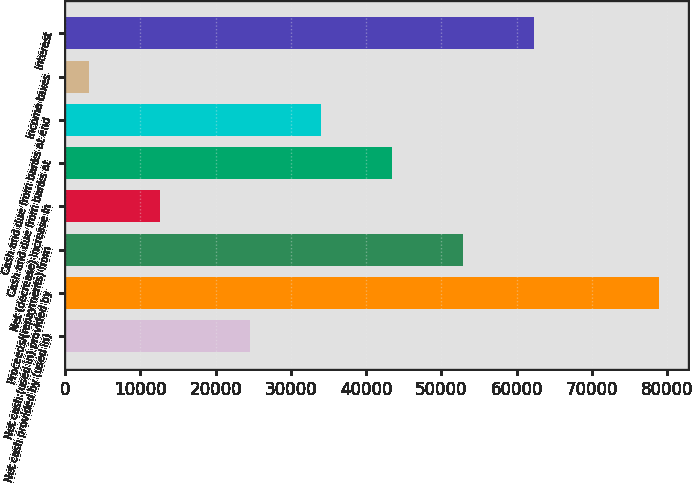Convert chart to OTSL. <chart><loc_0><loc_0><loc_500><loc_500><bar_chart><fcel>Net cash provided by (used in)<fcel>Net cash (used in) provided by<fcel>Proceeds/(repayments) from<fcel>Net (decrease) increase in<fcel>Cash and due from banks at<fcel>Cash and due from banks at end<fcel>Income taxes<fcel>Interest<nl><fcel>24537<fcel>78850<fcel>52891.8<fcel>12621.6<fcel>43440.2<fcel>33988.6<fcel>3170<fcel>62343.4<nl></chart> 